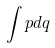<formula> <loc_0><loc_0><loc_500><loc_500>\int p d q</formula> 